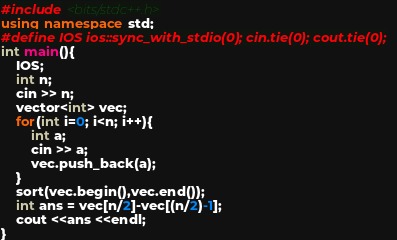<code> <loc_0><loc_0><loc_500><loc_500><_C++_>#include <bits/stdc++.h>
using namespace std;
#define IOS ios::sync_with_stdio(0); cin.tie(0); cout.tie(0);
int main(){
    IOS;
    int n;
    cin >> n;
    vector<int> vec;
    for(int i=0; i<n; i++){
        int a;
        cin >> a;
        vec.push_back(a);
    }
    sort(vec.begin(),vec.end());
    int ans = vec[n/2]-vec[(n/2)-1];
    cout <<ans <<endl;
}</code> 